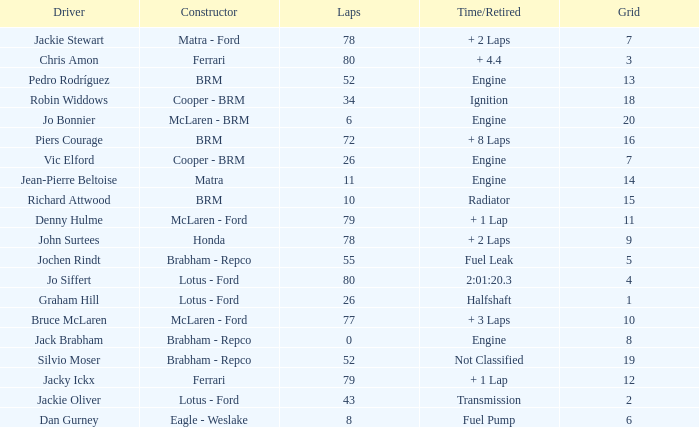I'm looking to parse the entire table for insights. Could you assist me with that? {'header': ['Driver', 'Constructor', 'Laps', 'Time/Retired', 'Grid'], 'rows': [['Jackie Stewart', 'Matra - Ford', '78', '+ 2 Laps', '7'], ['Chris Amon', 'Ferrari', '80', '+ 4.4', '3'], ['Pedro Rodríguez', 'BRM', '52', 'Engine', '13'], ['Robin Widdows', 'Cooper - BRM', '34', 'Ignition', '18'], ['Jo Bonnier', 'McLaren - BRM', '6', 'Engine', '20'], ['Piers Courage', 'BRM', '72', '+ 8 Laps', '16'], ['Vic Elford', 'Cooper - BRM', '26', 'Engine', '7'], ['Jean-Pierre Beltoise', 'Matra', '11', 'Engine', '14'], ['Richard Attwood', 'BRM', '10', 'Radiator', '15'], ['Denny Hulme', 'McLaren - Ford', '79', '+ 1 Lap', '11'], ['John Surtees', 'Honda', '78', '+ 2 Laps', '9'], ['Jochen Rindt', 'Brabham - Repco', '55', 'Fuel Leak', '5'], ['Jo Siffert', 'Lotus - Ford', '80', '2:01:20.3', '4'], ['Graham Hill', 'Lotus - Ford', '26', 'Halfshaft', '1'], ['Bruce McLaren', 'McLaren - Ford', '77', '+ 3 Laps', '10'], ['Jack Brabham', 'Brabham - Repco', '0', 'Engine', '8'], ['Silvio Moser', 'Brabham - Repco', '52', 'Not Classified', '19'], ['Jacky Ickx', 'Ferrari', '79', '+ 1 Lap', '12'], ['Jackie Oliver', 'Lotus - Ford', '43', 'Transmission', '2'], ['Dan Gurney', 'Eagle - Weslake', '8', 'Fuel Pump', '6']]} When the driver richard attwood has a constructor of brm, what is the number of laps? 10.0. 